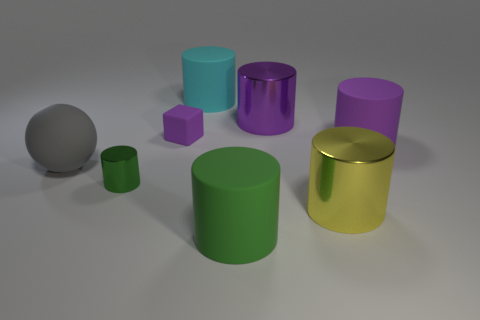How many purple cylinders must be subtracted to get 1 purple cylinders? 1 Subtract all large yellow cylinders. How many cylinders are left? 5 Add 1 green objects. How many objects exist? 9 Subtract all purple cylinders. How many cylinders are left? 4 Subtract all blue cubes. How many purple cylinders are left? 2 Subtract all cubes. How many objects are left? 7 Subtract 4 cylinders. How many cylinders are left? 2 Add 8 large cyan shiny cylinders. How many large cyan shiny cylinders exist? 8 Subtract 0 blue balls. How many objects are left? 8 Subtract all yellow blocks. Subtract all yellow cylinders. How many blocks are left? 1 